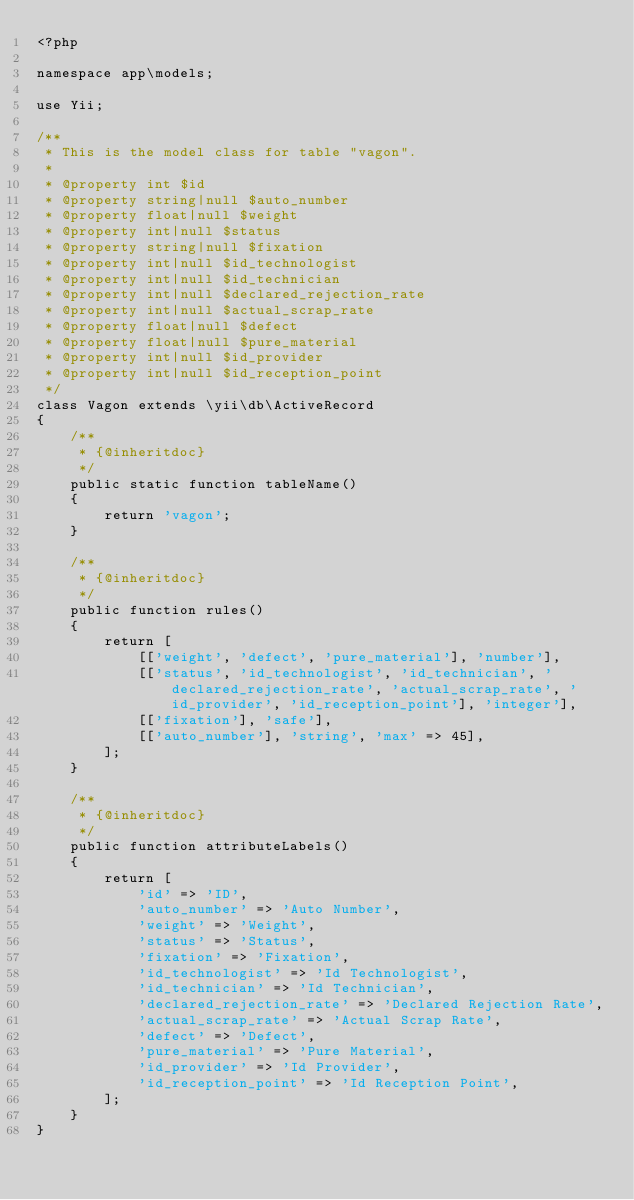<code> <loc_0><loc_0><loc_500><loc_500><_PHP_><?php

namespace app\models;

use Yii;

/**
 * This is the model class for table "vagon".
 *
 * @property int $id
 * @property string|null $auto_number
 * @property float|null $weight
 * @property int|null $status
 * @property string|null $fixation
 * @property int|null $id_technologist
 * @property int|null $id_technician
 * @property int|null $declared_rejection_rate
 * @property int|null $actual_scrap_rate
 * @property float|null $defect
 * @property float|null $pure_material
 * @property int|null $id_provider
 * @property int|null $id_reception_point
 */
class Vagon extends \yii\db\ActiveRecord
{
    /**
     * {@inheritdoc}
     */
    public static function tableName()
    {
        return 'vagon';
    }

    /**
     * {@inheritdoc}
     */
    public function rules()
    {
        return [
            [['weight', 'defect', 'pure_material'], 'number'],
            [['status', 'id_technologist', 'id_technician', 'declared_rejection_rate', 'actual_scrap_rate', 'id_provider', 'id_reception_point'], 'integer'],
            [['fixation'], 'safe'],
            [['auto_number'], 'string', 'max' => 45],
        ];
    }

    /**
     * {@inheritdoc}
     */
    public function attributeLabels()
    {
        return [
            'id' => 'ID',
            'auto_number' => 'Auto Number',
            'weight' => 'Weight',
            'status' => 'Status',
            'fixation' => 'Fixation',
            'id_technologist' => 'Id Technologist',
            'id_technician' => 'Id Technician',
            'declared_rejection_rate' => 'Declared Rejection Rate',
            'actual_scrap_rate' => 'Actual Scrap Rate',
            'defect' => 'Defect',
            'pure_material' => 'Pure Material',
            'id_provider' => 'Id Provider',
            'id_reception_point' => 'Id Reception Point',
        ];
    }
}
</code> 